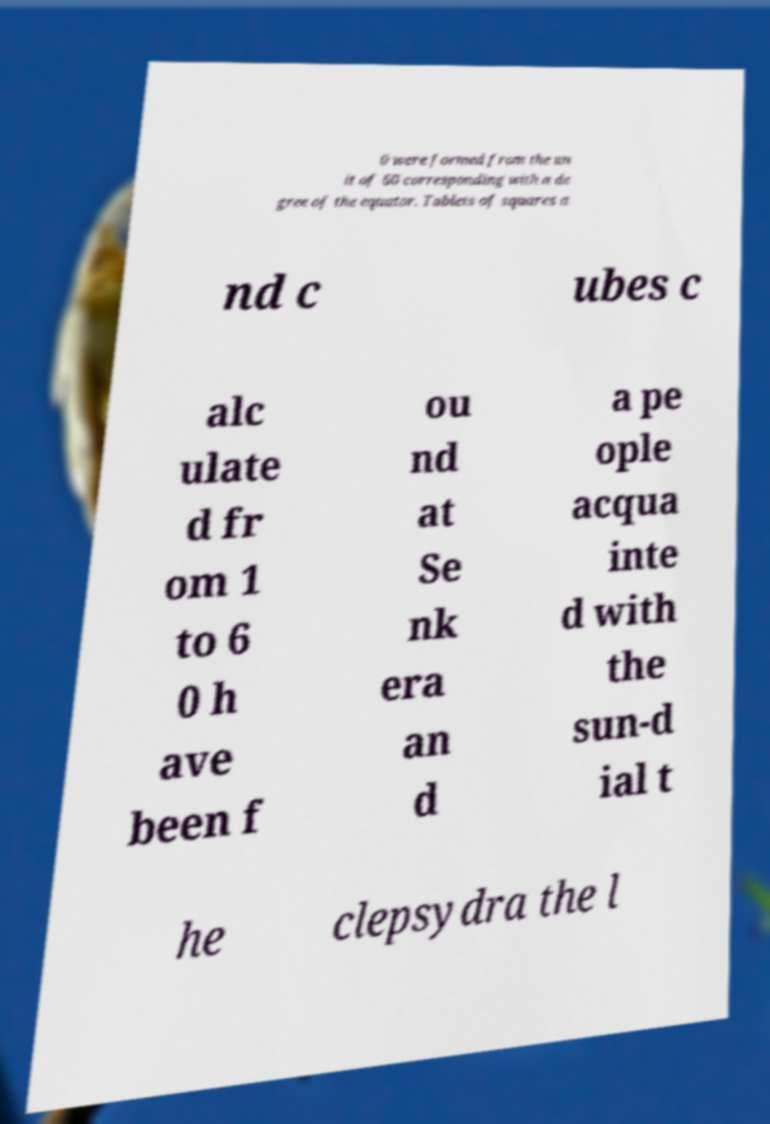Could you assist in decoding the text presented in this image and type it out clearly? 0 were formed from the un it of 60 corresponding with a de gree of the equator. Tablets of squares a nd c ubes c alc ulate d fr om 1 to 6 0 h ave been f ou nd at Se nk era an d a pe ople acqua inte d with the sun-d ial t he clepsydra the l 